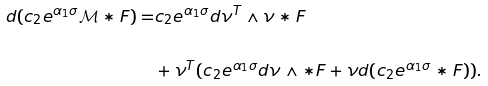<formula> <loc_0><loc_0><loc_500><loc_500>d ( c _ { 2 } e ^ { \alpha _ { 1 } \sigma } \mathcal { M } \ast F ) = & c _ { 2 } e ^ { \alpha _ { 1 } \sigma } d \nu ^ { T } \wedge \nu \ast F \\ \\ & + \nu ^ { T } ( c _ { 2 } e ^ { \alpha _ { 1 } \sigma } d \nu \wedge \ast F + \nu d ( c _ { 2 } e ^ { \alpha _ { 1 } \sigma } \ast F ) ) .</formula> 